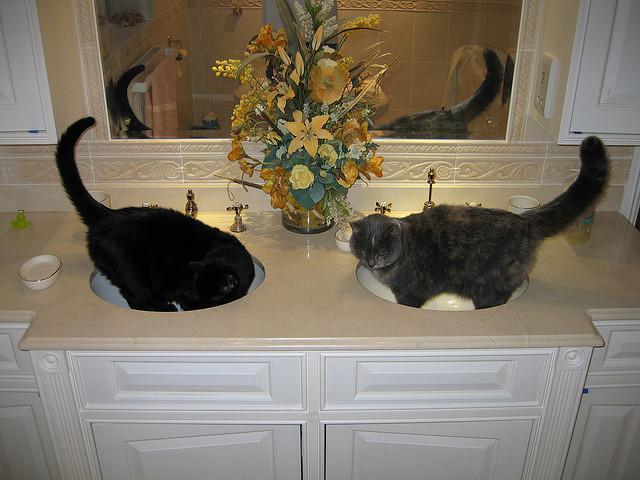How many animals are there?
Give a very brief answer. 2. How many cats are in the photo?
Give a very brief answer. 2. 